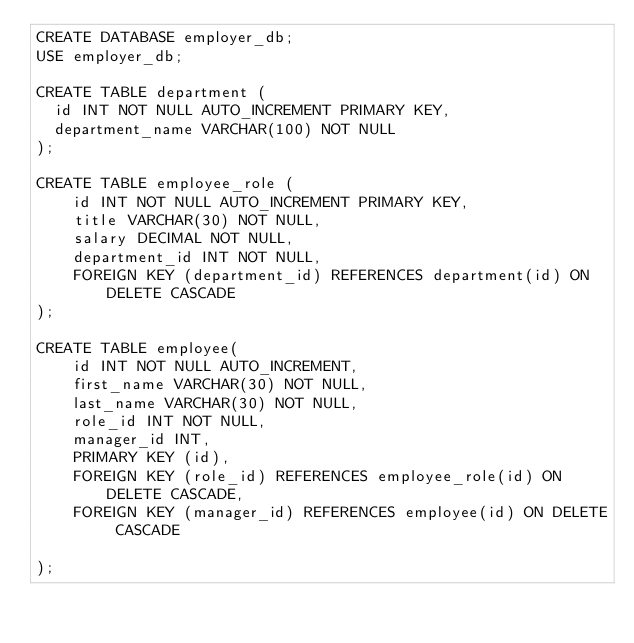Convert code to text. <code><loc_0><loc_0><loc_500><loc_500><_SQL_>CREATE DATABASE employer_db;
USE employer_db;

CREATE TABLE department (
  id INT NOT NULL AUTO_INCREMENT PRIMARY KEY,
  department_name VARCHAR(100) NOT NULL
);

CREATE TABLE employee_role (
    id INT NOT NULL AUTO_INCREMENT PRIMARY KEY,
    title VARCHAR(30) NOT NULL,
    salary DECIMAL NOT NULL,
    department_id INT NOT NULL,
    FOREIGN KEY (department_id) REFERENCES department(id) ON DELETE CASCADE
);

CREATE TABLE employee(
    id INT NOT NULL AUTO_INCREMENT,
    first_name VARCHAR(30) NOT NULL,
    last_name VARCHAR(30) NOT NULL,
    role_id INT NOT NULL,
    manager_id INT, 
    PRIMARY KEY (id),
    FOREIGN KEY (role_id) REFERENCES employee_role(id) ON DELETE CASCADE,
    FOREIGN KEY (manager_id) REFERENCES employee(id) ON DELETE CASCADE

);</code> 